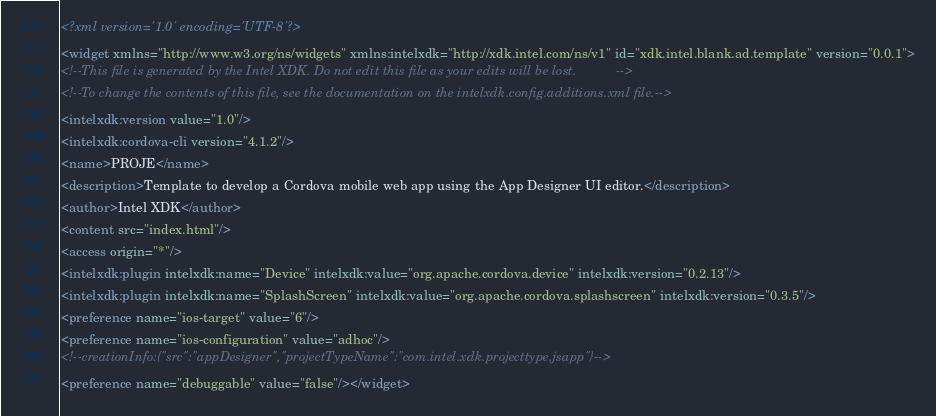Convert code to text. <code><loc_0><loc_0><loc_500><loc_500><_XML_><?xml version='1.0' encoding='UTF-8'?>
<widget xmlns="http://www.w3.org/ns/widgets" xmlns:intelxdk="http://xdk.intel.com/ns/v1" id="xdk.intel.blank.ad.template" version="0.0.1">
<!--This file is generated by the Intel XDK. Do not edit this file as your edits will be lost.           -->
<!--To change the contents of this file, see the documentation on the intelxdk.config.additions.xml file.-->
<intelxdk:version value="1.0"/>
<intelxdk:cordova-cli version="4.1.2"/>
<name>PROJE</name>
<description>Template to develop a Cordova mobile web app using the App Designer UI editor.</description>
<author>Intel XDK</author>
<content src="index.html"/>
<access origin="*"/>
<intelxdk:plugin intelxdk:name="Device" intelxdk:value="org.apache.cordova.device" intelxdk:version="0.2.13"/>
<intelxdk:plugin intelxdk:name="SplashScreen" intelxdk:value="org.apache.cordova.splashscreen" intelxdk:version="0.3.5"/>
<preference name="ios-target" value="6"/>
<preference name="ios-configuration" value="adhoc"/>
<!--creationInfo:{"src":"appDesigner","projectTypeName":"com.intel.xdk.projecttype.jsapp"}-->
<preference name="debuggable" value="false"/></widget></code> 